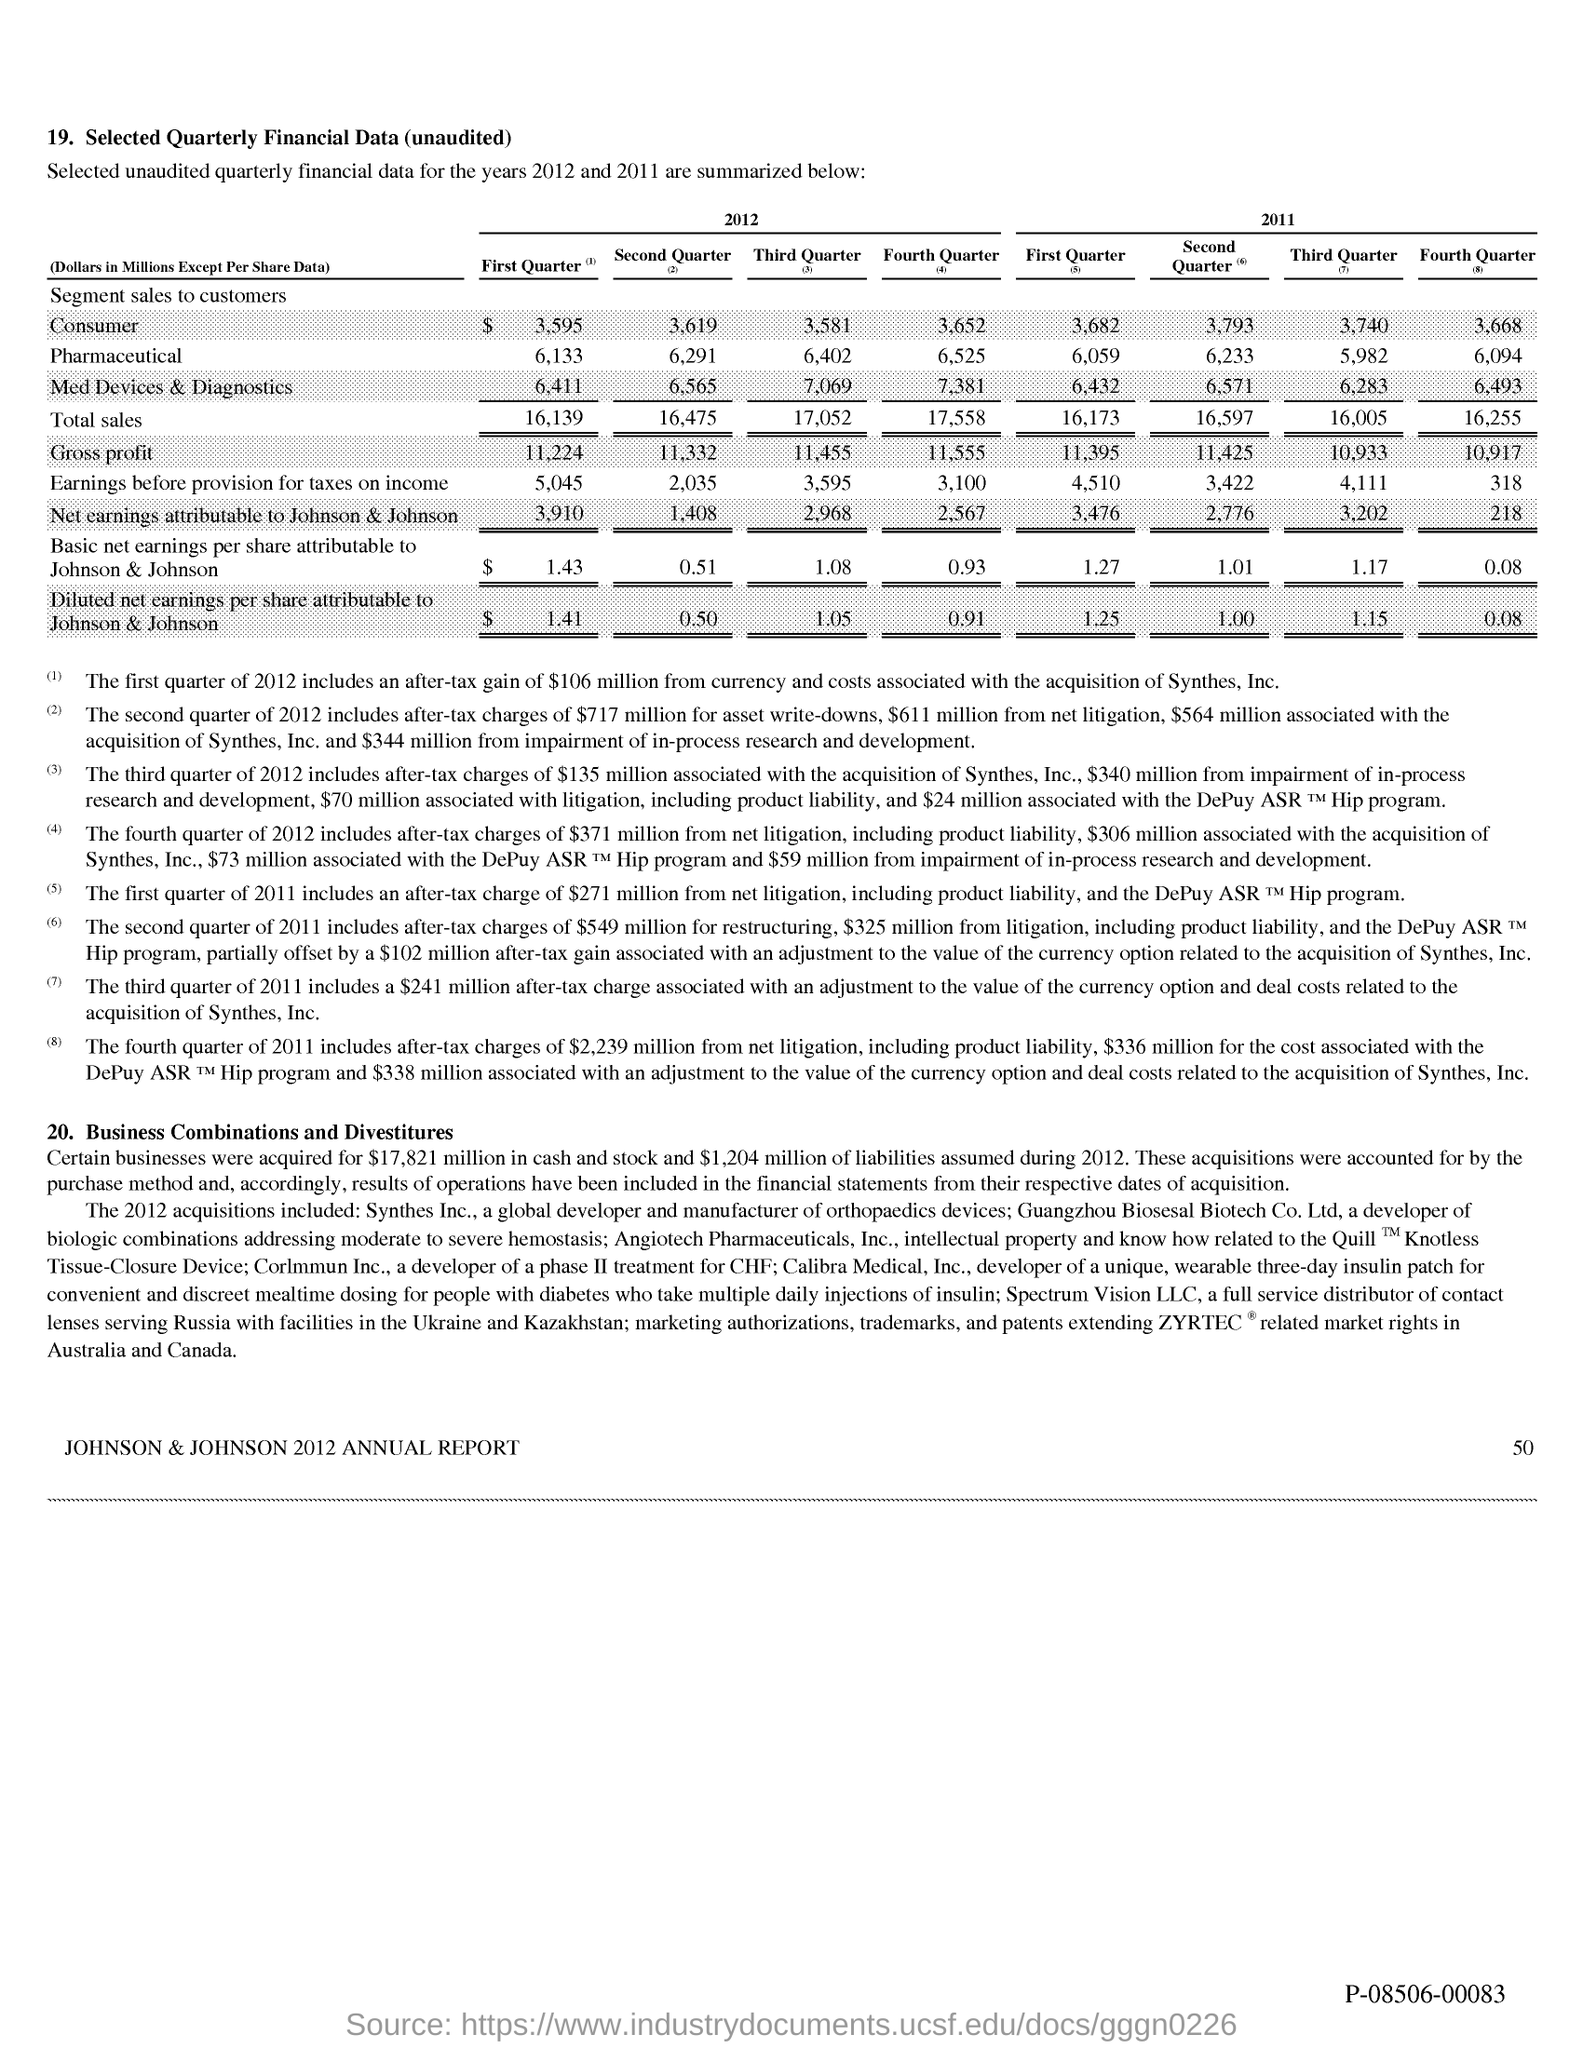Draw attention to some important aspects in this diagram. The total sales for the first quarter of 2011 were 16.173 billion dollars, except for per share data. In the first quarter of 2012, the total sales were 16.1 billion dollars, with the exception of per share data. In the first quarter of 2012, Johnson & Johnson's basic net earnings per share were $1.43, excluding any adjustments or subtractions. The net earnings attributable to Johnson & Johnson in the first quarter of 2011 were $3,476 million, excluding any per share data. Johnson & Johnson's net earnings for the second quarter of 2012 were $1,408 million. 